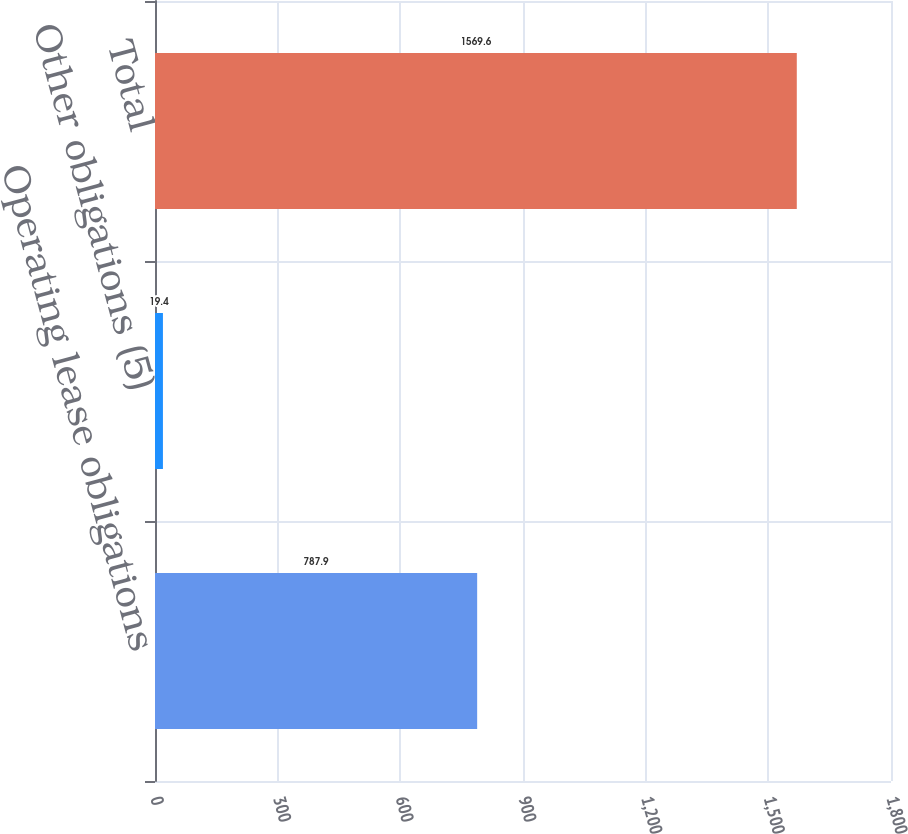Convert chart to OTSL. <chart><loc_0><loc_0><loc_500><loc_500><bar_chart><fcel>Operating lease obligations<fcel>Other obligations (5)<fcel>Total<nl><fcel>787.9<fcel>19.4<fcel>1569.6<nl></chart> 